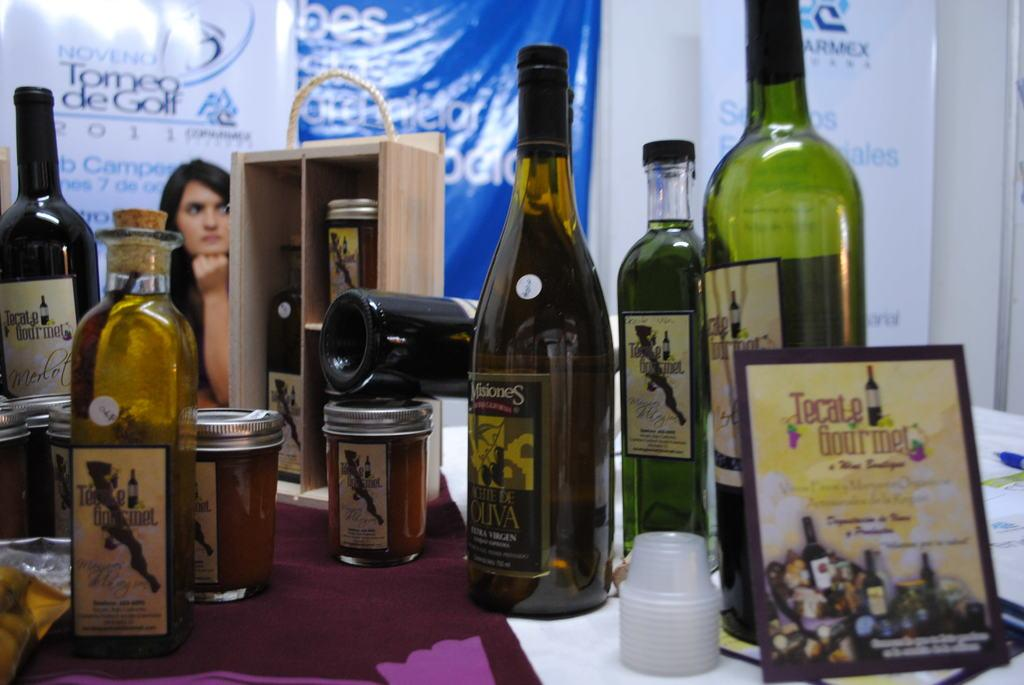<image>
Describe the image concisely. A bottle of Misiones wine on a table. 